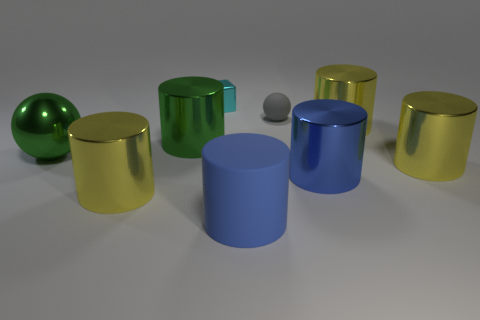How many other objects are there of the same size as the cyan thing?
Offer a terse response. 1. What size is the other cylinder that is the same color as the rubber cylinder?
Your answer should be compact. Large. What number of cylinders are either big green matte things or big yellow objects?
Your answer should be compact. 3. There is a yellow object that is on the left side of the cyan shiny block; is it the same shape as the big matte thing?
Provide a short and direct response. Yes. Is the number of large metallic things that are in front of the cyan metal block greater than the number of gray rubber spheres?
Keep it short and to the point. Yes. There is a thing that is the same size as the cyan cube; what is its color?
Your answer should be compact. Gray. How many objects are big metallic objects right of the small cube or large red matte spheres?
Your answer should be compact. 3. There is a thing that is the same color as the matte cylinder; what shape is it?
Offer a very short reply. Cylinder. What is the material of the large blue cylinder on the left side of the matte thing that is behind the large blue metallic thing?
Keep it short and to the point. Rubber. Are there any green cylinders made of the same material as the cyan object?
Provide a succinct answer. Yes. 